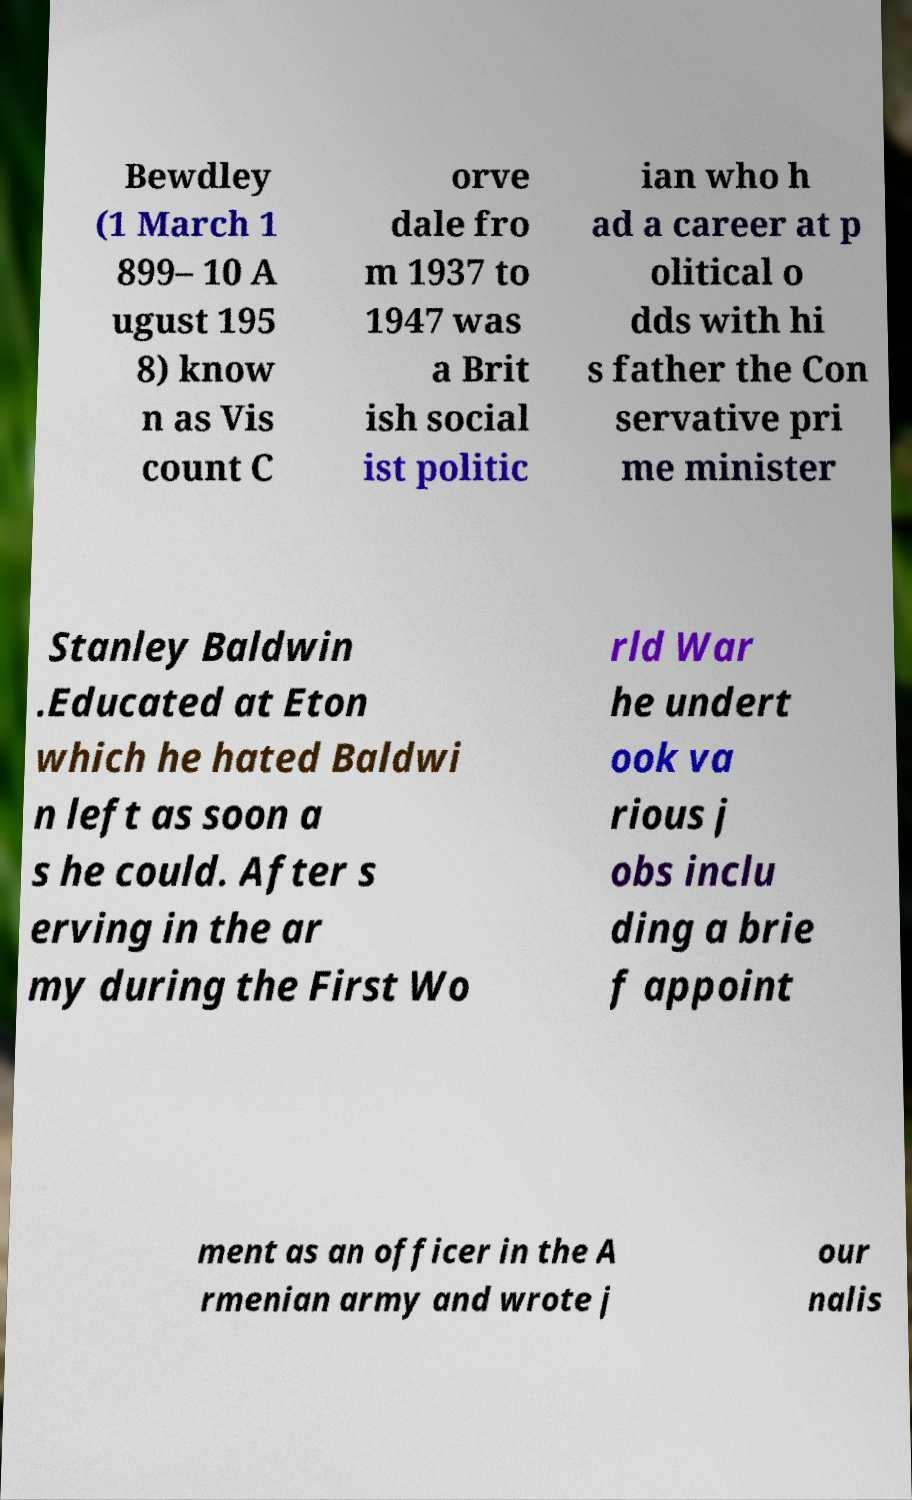Please identify and transcribe the text found in this image. Bewdley (1 March 1 899– 10 A ugust 195 8) know n as Vis count C orve dale fro m 1937 to 1947 was a Brit ish social ist politic ian who h ad a career at p olitical o dds with hi s father the Con servative pri me minister Stanley Baldwin .Educated at Eton which he hated Baldwi n left as soon a s he could. After s erving in the ar my during the First Wo rld War he undert ook va rious j obs inclu ding a brie f appoint ment as an officer in the A rmenian army and wrote j our nalis 